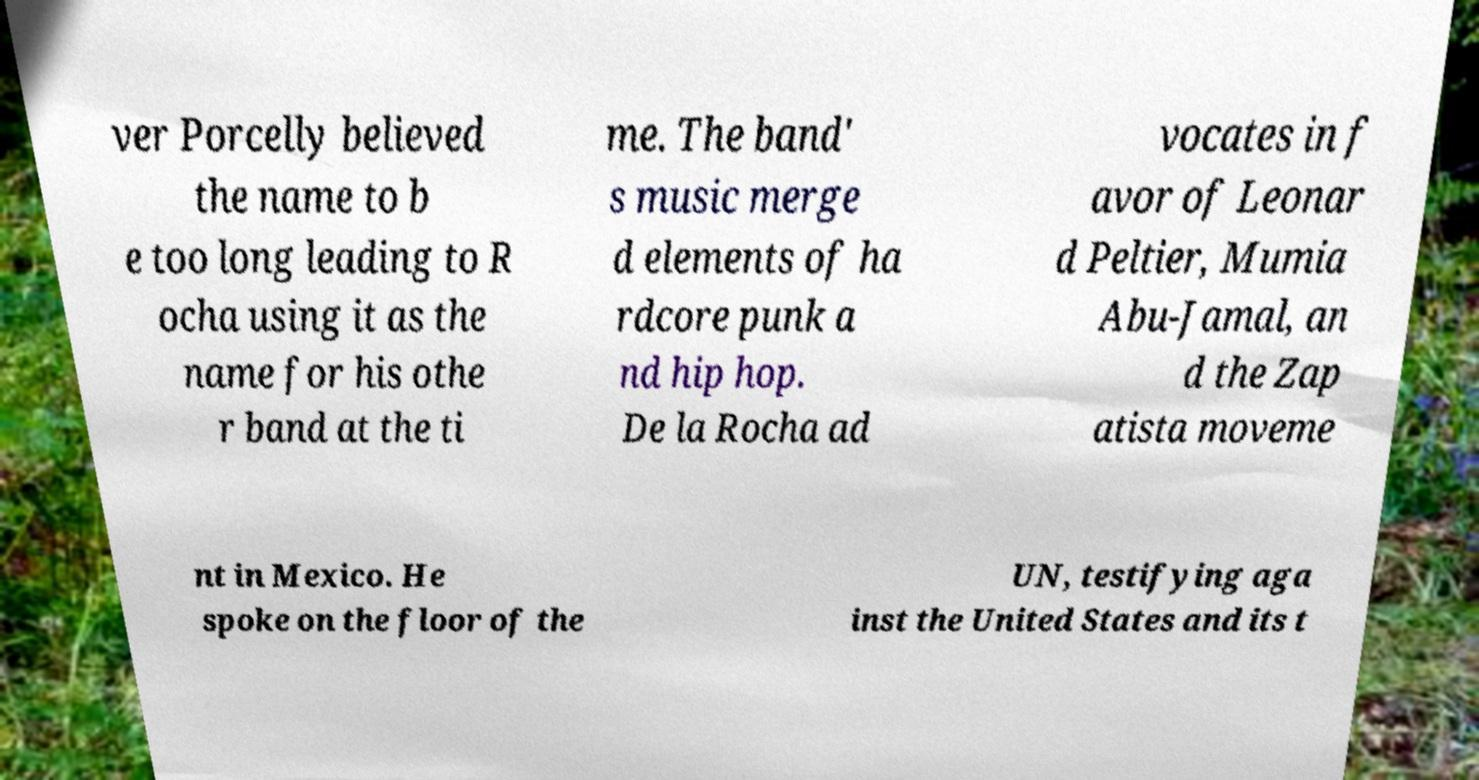Can you read and provide the text displayed in the image?This photo seems to have some interesting text. Can you extract and type it out for me? ver Porcelly believed the name to b e too long leading to R ocha using it as the name for his othe r band at the ti me. The band' s music merge d elements of ha rdcore punk a nd hip hop. De la Rocha ad vocates in f avor of Leonar d Peltier, Mumia Abu-Jamal, an d the Zap atista moveme nt in Mexico. He spoke on the floor of the UN, testifying aga inst the United States and its t 